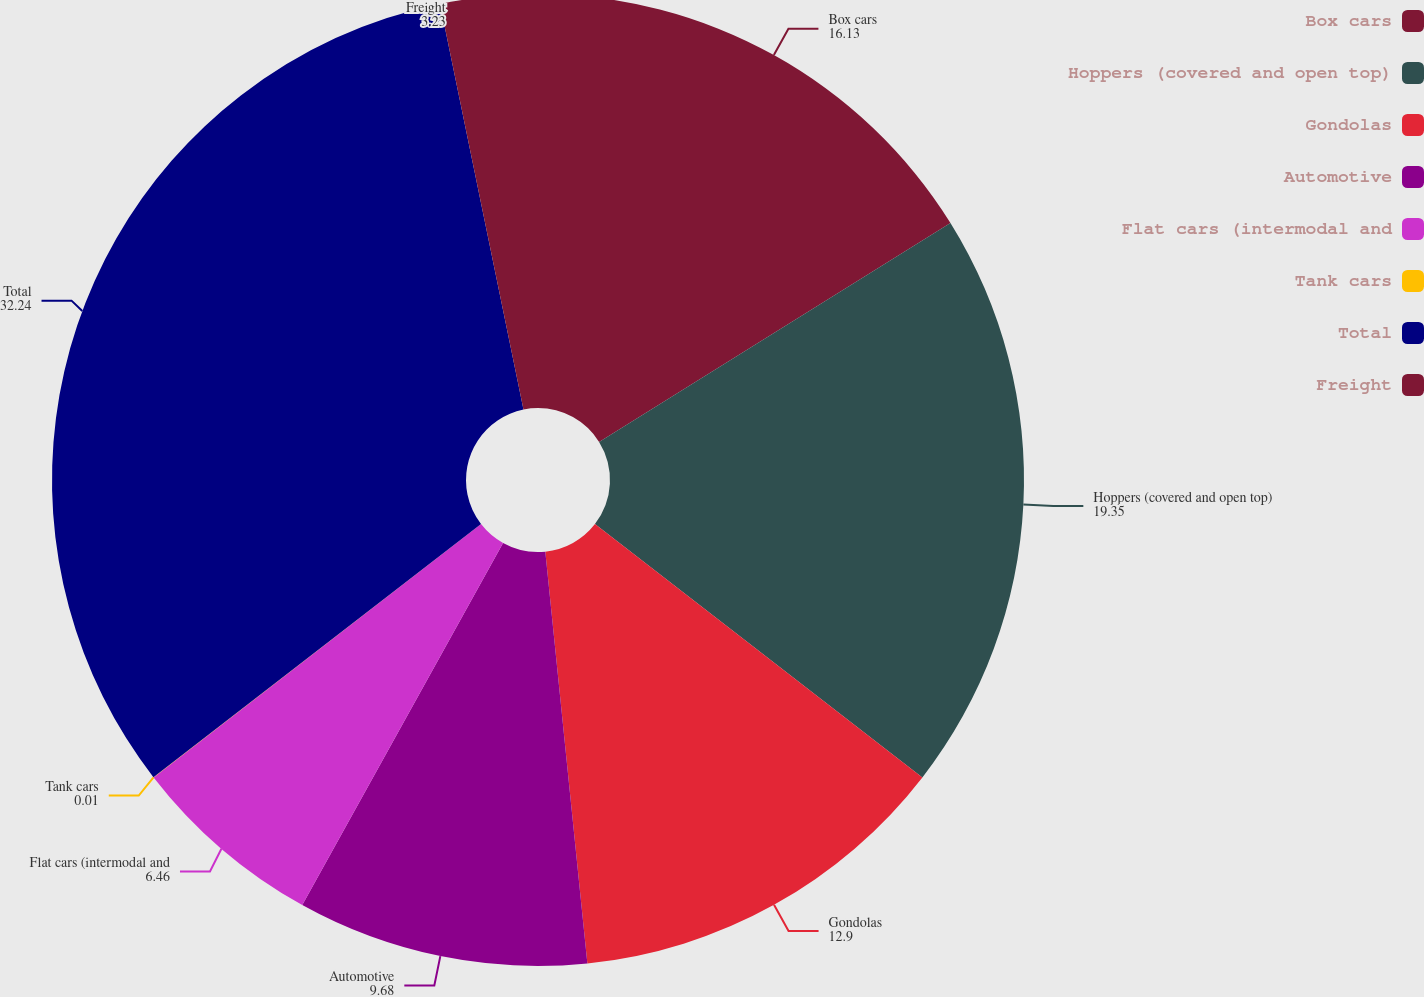<chart> <loc_0><loc_0><loc_500><loc_500><pie_chart><fcel>Box cars<fcel>Hoppers (covered and open top)<fcel>Gondolas<fcel>Automotive<fcel>Flat cars (intermodal and<fcel>Tank cars<fcel>Total<fcel>Freight<nl><fcel>16.13%<fcel>19.35%<fcel>12.9%<fcel>9.68%<fcel>6.46%<fcel>0.01%<fcel>32.24%<fcel>3.23%<nl></chart> 